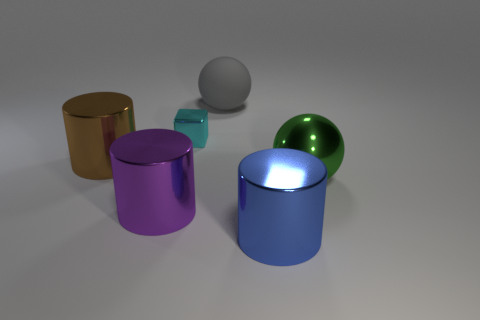What is the color of the ball in front of the matte sphere?
Your answer should be very brief. Green. Is there a cylinder of the same size as the cyan metal cube?
Your answer should be compact. No. There is a brown object that is the same size as the gray sphere; what material is it?
Your answer should be compact. Metal. What number of objects are either spheres on the right side of the gray sphere or big metal things that are in front of the large purple shiny object?
Provide a succinct answer. 2. Are there any other large green metallic things of the same shape as the green object?
Keep it short and to the point. No. What number of shiny objects are blocks or green objects?
Provide a succinct answer. 2. There is a purple metallic object; what shape is it?
Offer a terse response. Cylinder. What number of gray things have the same material as the big brown cylinder?
Your response must be concise. 0. There is a big sphere that is made of the same material as the blue thing; what color is it?
Ensure brevity in your answer.  Green. Does the object behind the cyan metal object have the same size as the large brown cylinder?
Provide a short and direct response. Yes. 